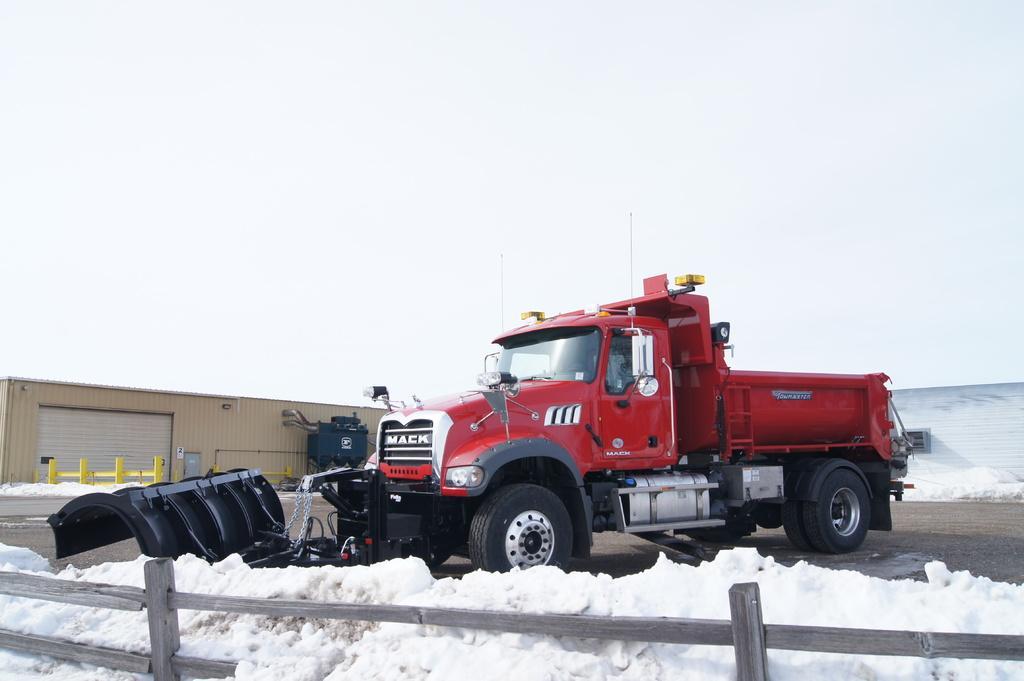Please provide a concise description of this image. In a given image i can see a vehicle,fence,snow and some other objects. 